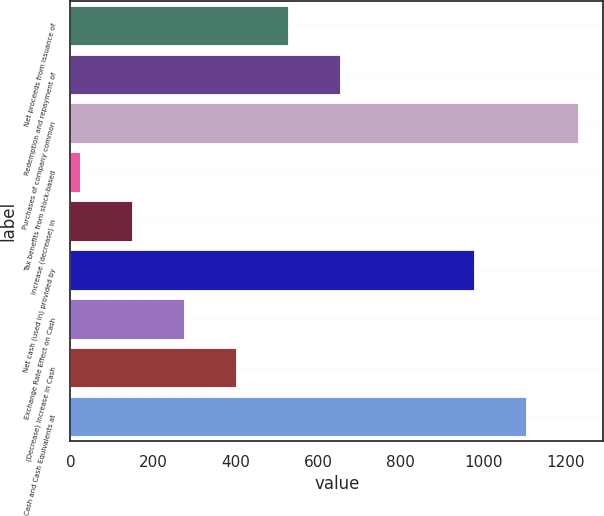Convert chart. <chart><loc_0><loc_0><loc_500><loc_500><bar_chart><fcel>Net proceeds from issuance of<fcel>Redemption and repayment of<fcel>Purchases of company common<fcel>Tax benefits from stock-based<fcel>Increase (decrease) in<fcel>Net cash (used in) provided by<fcel>Exchange Rate Effect on Cash<fcel>(Decrease) Increase in Cash<fcel>Cash and Cash Equivalents at<nl><fcel>526.46<fcel>652.4<fcel>1228.82<fcel>22.7<fcel>148.64<fcel>976.94<fcel>274.58<fcel>400.52<fcel>1102.88<nl></chart> 